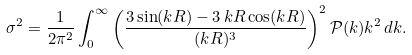<formula> <loc_0><loc_0><loc_500><loc_500>\sigma ^ { 2 } = \frac { 1 } { 2 \pi ^ { 2 } } \int _ { 0 } ^ { \infty } \left ( \frac { 3 \sin ( k R ) - 3 \, k R \cos ( k R ) } { ( k R ) ^ { 3 } } \right ) ^ { 2 } \mathcal { P } ( k ) k ^ { 2 } \, d k .</formula> 